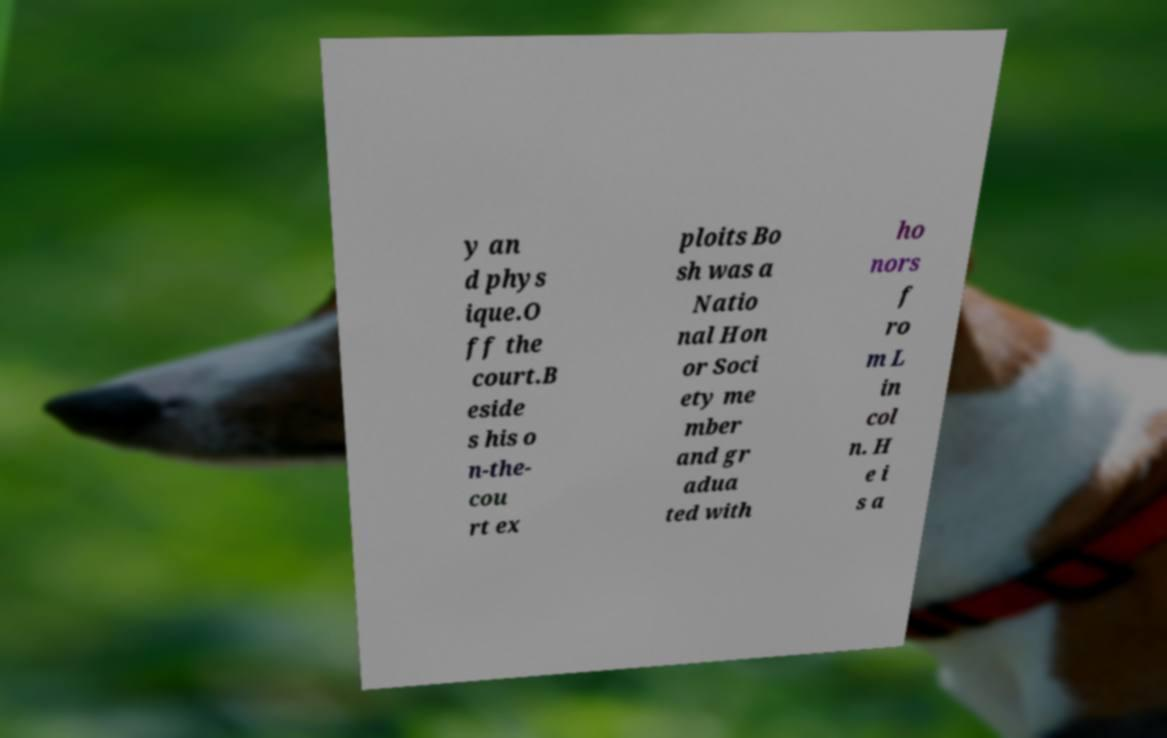I need the written content from this picture converted into text. Can you do that? y an d phys ique.O ff the court.B eside s his o n-the- cou rt ex ploits Bo sh was a Natio nal Hon or Soci ety me mber and gr adua ted with ho nors f ro m L in col n. H e i s a 